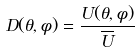Convert formula to latex. <formula><loc_0><loc_0><loc_500><loc_500>D ( \theta , \phi ) = \frac { U ( \theta , \phi ) } { \overline { U } }</formula> 